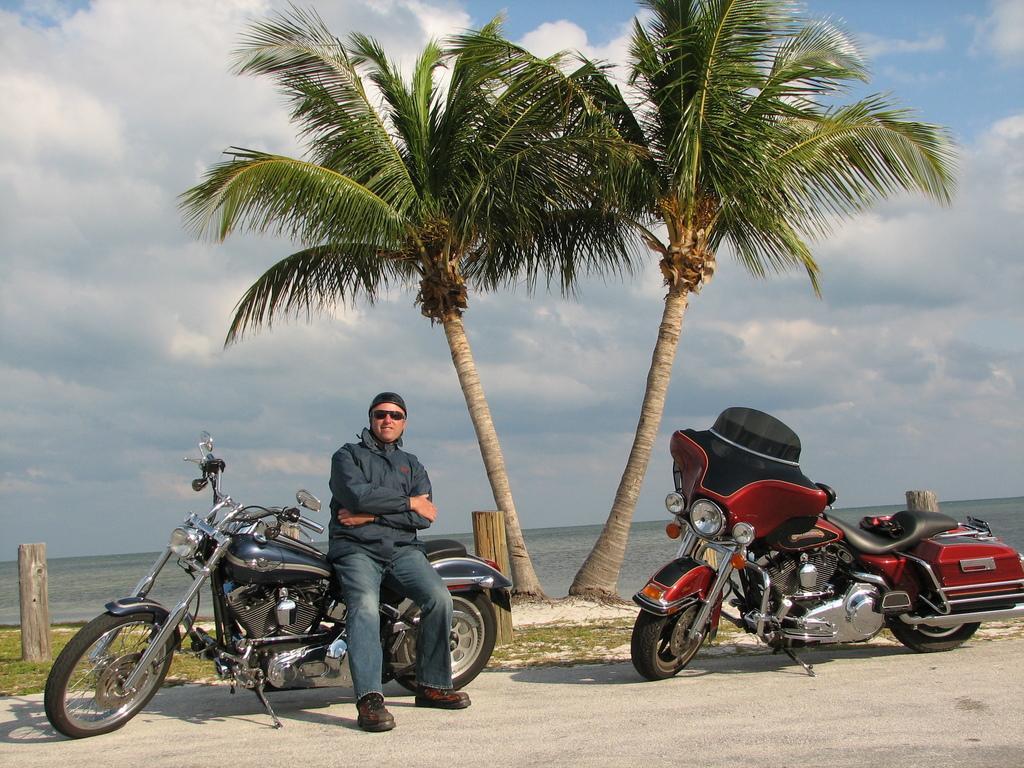Could you give a brief overview of what you see in this image? In this image I can see a man and two bikes. In the background I can see two trees and a cloudy sky. 